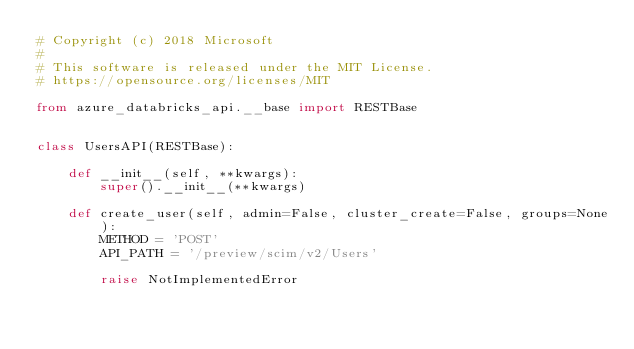<code> <loc_0><loc_0><loc_500><loc_500><_Python_># Copyright (c) 2018 Microsoft
#
# This software is released under the MIT License.
# https://opensource.org/licenses/MIT

from azure_databricks_api.__base import RESTBase


class UsersAPI(RESTBase):

    def __init__(self, **kwargs):
        super().__init__(**kwargs)

    def create_user(self, admin=False, cluster_create=False, groups=None):
        METHOD = 'POST'
        API_PATH = '/preview/scim/v2/Users'

        raise NotImplementedError

</code> 